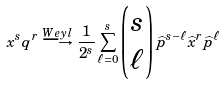<formula> <loc_0><loc_0><loc_500><loc_500>x ^ { s } q ^ { r } \overset { W e y l } { \longrightarrow } \frac { 1 } { 2 ^ { s } } \sum _ { \ell = 0 } ^ { s } \begin{pmatrix} s \\ \ell \end{pmatrix} \widehat { p } ^ { s - \ell } \widehat { x } ^ { r } \widehat { p } ^ { \ell }</formula> 